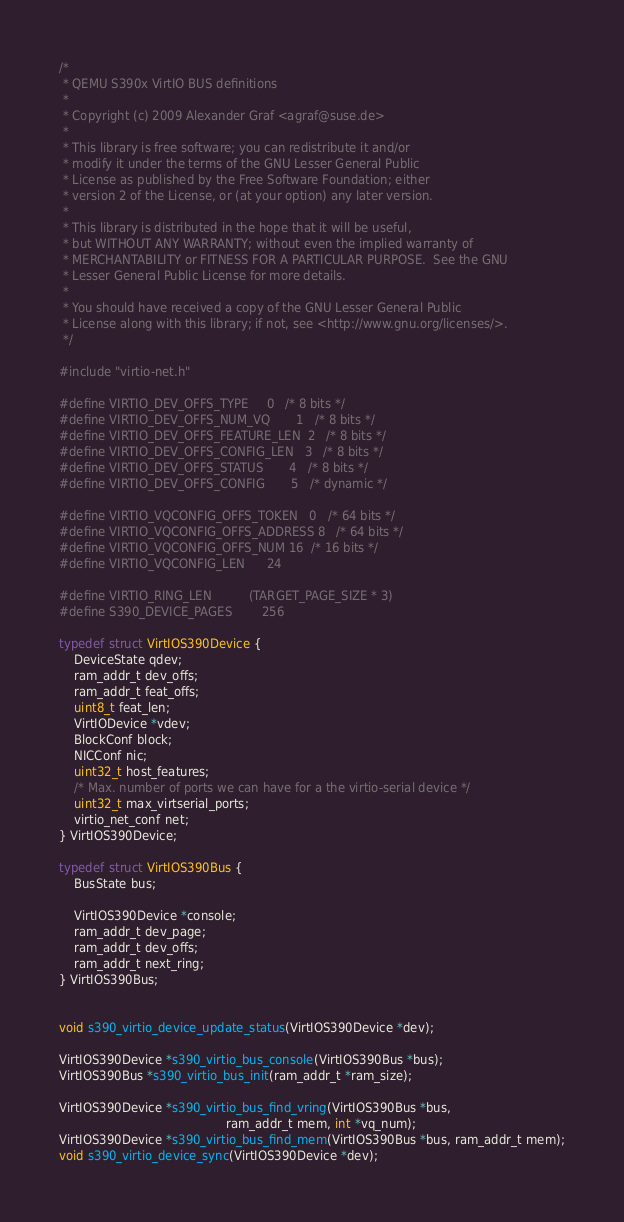<code> <loc_0><loc_0><loc_500><loc_500><_C_>/*
 * QEMU S390x VirtIO BUS definitions
 *
 * Copyright (c) 2009 Alexander Graf <agraf@suse.de>
 *
 * This library is free software; you can redistribute it and/or
 * modify it under the terms of the GNU Lesser General Public
 * License as published by the Free Software Foundation; either
 * version 2 of the License, or (at your option) any later version.
 *
 * This library is distributed in the hope that it will be useful,
 * but WITHOUT ANY WARRANTY; without even the implied warranty of
 * MERCHANTABILITY or FITNESS FOR A PARTICULAR PURPOSE.  See the GNU
 * Lesser General Public License for more details.
 *
 * You should have received a copy of the GNU Lesser General Public
 * License along with this library; if not, see <http://www.gnu.org/licenses/>.
 */

#include "virtio-net.h"

#define VIRTIO_DEV_OFFS_TYPE		0	/* 8 bits */
#define VIRTIO_DEV_OFFS_NUM_VQ		1	/* 8 bits */
#define VIRTIO_DEV_OFFS_FEATURE_LEN	2	/* 8 bits */
#define VIRTIO_DEV_OFFS_CONFIG_LEN	3	/* 8 bits */
#define VIRTIO_DEV_OFFS_STATUS		4	/* 8 bits */
#define VIRTIO_DEV_OFFS_CONFIG		5	/* dynamic */

#define VIRTIO_VQCONFIG_OFFS_TOKEN	0	/* 64 bits */
#define VIRTIO_VQCONFIG_OFFS_ADDRESS	8	/* 64 bits */
#define VIRTIO_VQCONFIG_OFFS_NUM	16	/* 16 bits */
#define VIRTIO_VQCONFIG_LEN		24

#define VIRTIO_RING_LEN			(TARGET_PAGE_SIZE * 3)
#define S390_DEVICE_PAGES		256

typedef struct VirtIOS390Device {
    DeviceState qdev;
    ram_addr_t dev_offs;
    ram_addr_t feat_offs;
    uint8_t feat_len;
    VirtIODevice *vdev;
    BlockConf block;
    NICConf nic;
    uint32_t host_features;
    /* Max. number of ports we can have for a the virtio-serial device */
    uint32_t max_virtserial_ports;
    virtio_net_conf net;
} VirtIOS390Device;

typedef struct VirtIOS390Bus {
    BusState bus;

    VirtIOS390Device *console;
    ram_addr_t dev_page;
    ram_addr_t dev_offs;
    ram_addr_t next_ring;
} VirtIOS390Bus;


void s390_virtio_device_update_status(VirtIOS390Device *dev);

VirtIOS390Device *s390_virtio_bus_console(VirtIOS390Bus *bus);
VirtIOS390Bus *s390_virtio_bus_init(ram_addr_t *ram_size);

VirtIOS390Device *s390_virtio_bus_find_vring(VirtIOS390Bus *bus,
                                             ram_addr_t mem, int *vq_num);
VirtIOS390Device *s390_virtio_bus_find_mem(VirtIOS390Bus *bus, ram_addr_t mem);
void s390_virtio_device_sync(VirtIOS390Device *dev);
</code> 